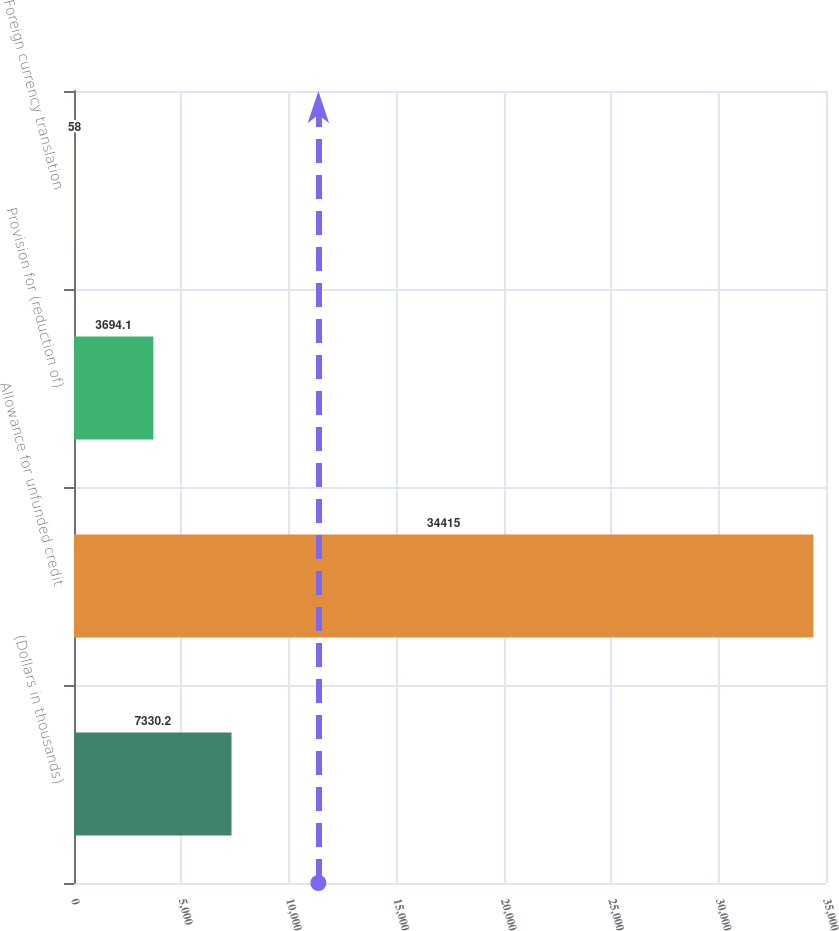Convert chart to OTSL. <chart><loc_0><loc_0><loc_500><loc_500><bar_chart><fcel>(Dollars in thousands)<fcel>Allowance for unfunded credit<fcel>Provision for (reduction of)<fcel>Foreign currency translation<nl><fcel>7330.2<fcel>34415<fcel>3694.1<fcel>58<nl></chart> 